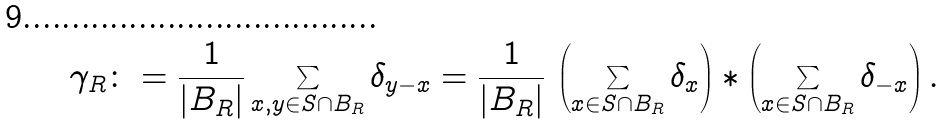Convert formula to latex. <formula><loc_0><loc_0><loc_500><loc_500>\gamma _ { R } \colon = \frac { 1 } { | B _ { R } | } \sum _ { x , y \in S \cap B _ { R } } \delta _ { y - x } = \frac { 1 } { | B _ { R } | } \, \left ( \sum _ { x \in S \cap B _ { R } } \delta _ { x } \right ) * \left ( \sum _ { x \in S \cap B _ { R } } \delta _ { - x } \right ) .</formula> 